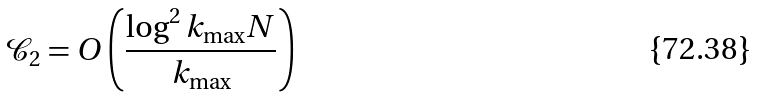<formula> <loc_0><loc_0><loc_500><loc_500>\mathcal { C } _ { 2 } = O \left ( \frac { \log ^ { 2 } k _ { \max } N } { k _ { \max } } \right )</formula> 